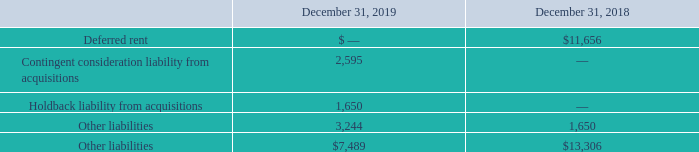Note 12. Liabilities
The components of accounts payable, accrued expenses and other current liabilities are as follows (in thousands):
Which years does the table provide information for the components of accounts payable, accrued expenses and other current liabilities? 2019, 2018. How much were other liabilities in 2019?
Answer scale should be: thousand. 3,244. How much was the deferred rent in 2018?
Answer scale should be: thousand. 11,656. What was the change in Other liabilities between 2018 and 2019?
Answer scale should be: thousand. 3,244-1,650
Answer: 1594. How many liabilities in 2019 exceeded $2,000 thousand? Contingent consideration liability from acquisitions##Other liabilities
Answer: 2. What was the percentage change in total other liabilities between 2018 and 2019?
Answer scale should be: percent. (7,489-13,306)/13,306
Answer: -43.72. 